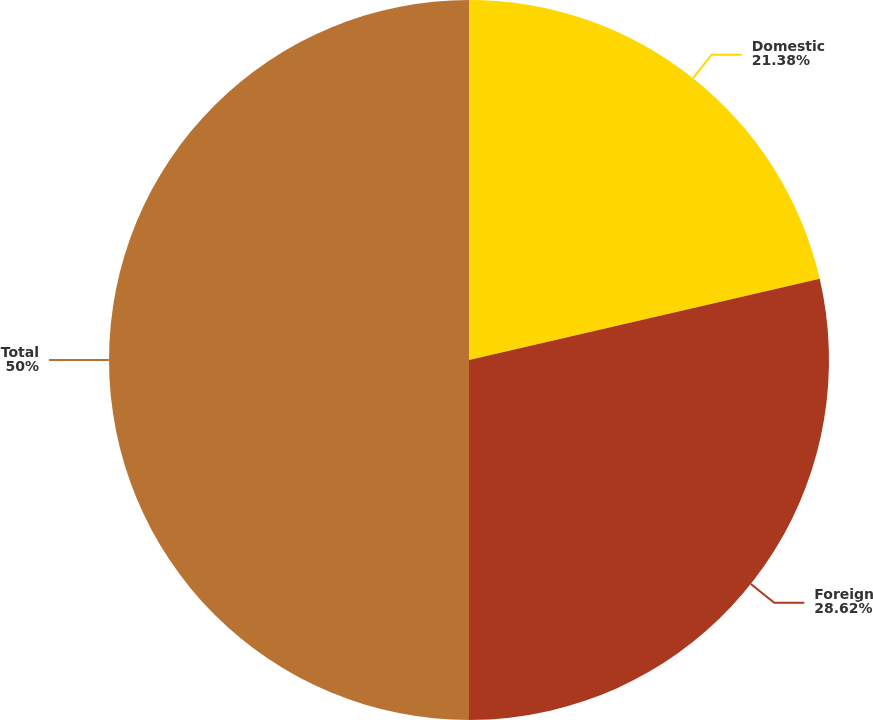Convert chart to OTSL. <chart><loc_0><loc_0><loc_500><loc_500><pie_chart><fcel>Domestic<fcel>Foreign<fcel>Total<nl><fcel>21.38%<fcel>28.62%<fcel>50.0%<nl></chart> 